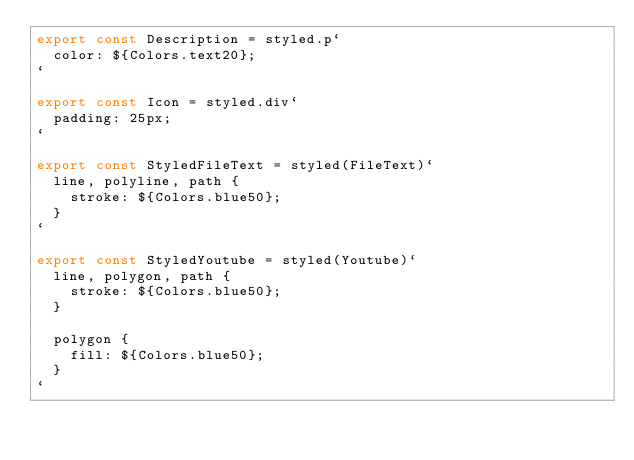<code> <loc_0><loc_0><loc_500><loc_500><_JavaScript_>export const Description = styled.p`
  color: ${Colors.text20};
`

export const Icon = styled.div`
  padding: 25px;
`

export const StyledFileText = styled(FileText)`
  line, polyline, path {
    stroke: ${Colors.blue50};
  }
`

export const StyledYoutube = styled(Youtube)`
  line, polygon, path {
    stroke: ${Colors.blue50};
  }

  polygon {
    fill: ${Colors.blue50};
  }
`
</code> 